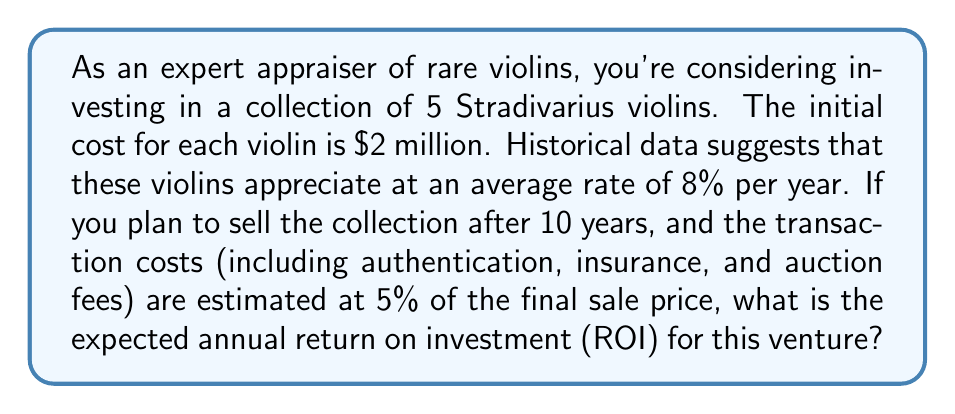Could you help me with this problem? Let's approach this problem step-by-step:

1) First, calculate the expected value of each violin after 10 years:
   $V_{10} = V_0 \times (1 + r)^t$
   Where $V_0$ is the initial value, $r$ is the annual appreciation rate, and $t$ is the time in years.
   
   $V_{10} = \$2,000,000 \times (1 + 0.08)^{10} = \$4,317,850.16$

2) The total value of the collection after 10 years:
   $V_{total} = 5 \times \$4,317,850.16 = \$21,589,250.80$

3) Account for transaction costs:
   Net sale value = $\$21,589,250.80 \times (1 - 0.05) = \$20,509,788.26$

4) Calculate the total profit:
   Profit = Net sale value - Initial investment
   $\$20,509,788.26 - (5 \times \$2,000,000) = \$10,509,788.26$

5) To find the annual ROI, we use the formula:
   $ROI = \left(\frac{FV}{PV}\right)^{\frac{1}{t}} - 1$
   Where $FV$ is the future value (net sale value), $PV$ is the present value (initial investment), and $t$ is the time in years.

   $ROI = \left(\frac{\$20,509,788.26}{\$10,000,000}\right)^{\frac{1}{10}} - 1$
   $ROI = (2.0509788)^{0.1} - 1$
   $ROI = 0.0744 = 7.44\%$
Answer: The expected annual return on investment (ROI) for purchasing and reselling the collection of rare Stradivarius violins over 10 years is approximately 7.44%. 